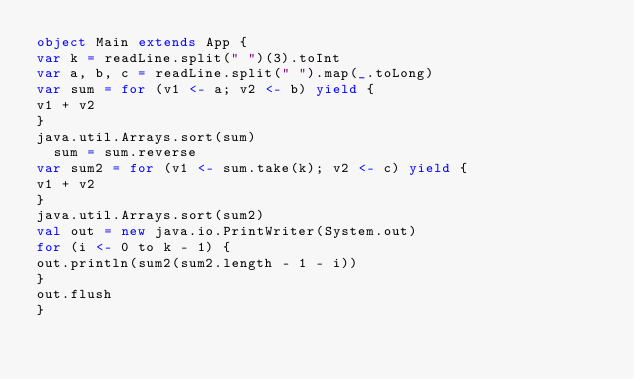<code> <loc_0><loc_0><loc_500><loc_500><_Scala_>object Main extends App {
var k = readLine.split(" ")(3).toInt
var a, b, c = readLine.split(" ").map(_.toLong)
var sum = for (v1 <- a; v2 <- b) yield {
v1 + v2
}
java.util.Arrays.sort(sum)
  sum = sum.reverse
var sum2 = for (v1 <- sum.take(k); v2 <- c) yield {
v1 + v2
}
java.util.Arrays.sort(sum2)
val out = new java.io.PrintWriter(System.out)
for (i <- 0 to k - 1) {
out.println(sum2(sum2.length - 1 - i))
}
out.flush
}</code> 